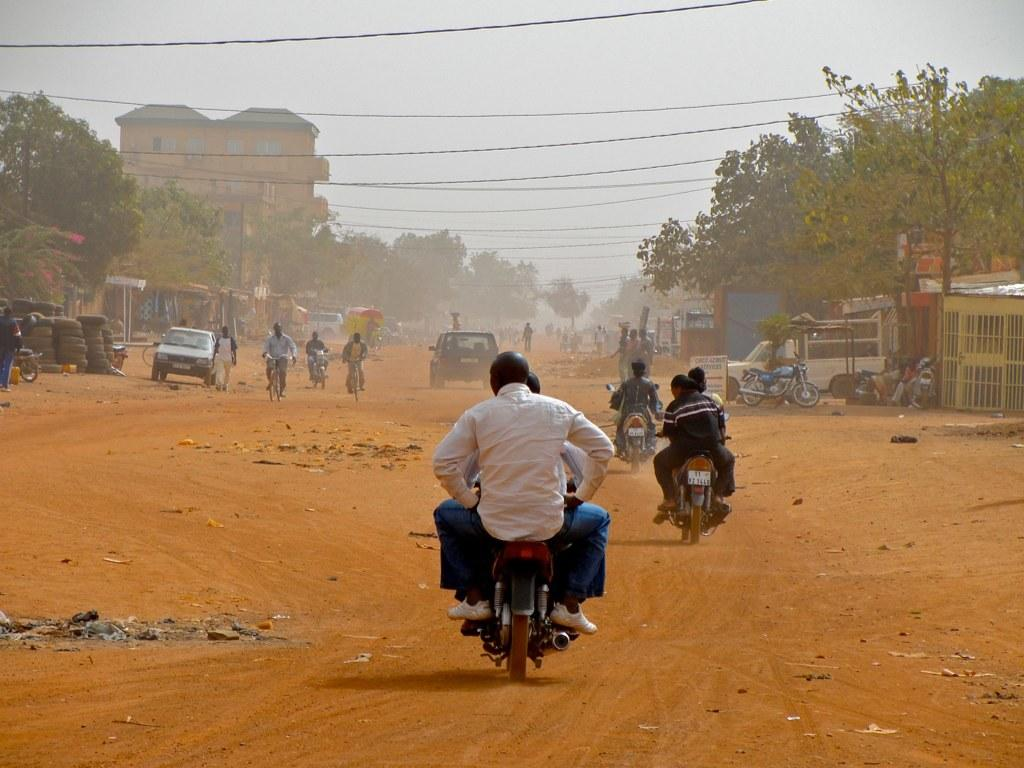What are the people in the image using to travel? The people in the image are using bicycles to travel. What type of vehicles can be seen in the image? There are vehicles in the image, but they are not specified. What is located in the foreground of the image? There are stalls in the foreground area of the image. What can be seen in the background of the image? Trees, buildings, and the sky are visible in the background of the image. Can you tell me how many bubbles are floating around the monkey in the image? There is no monkey or bubble present in the image. What type of curve can be seen on the bicycle in the image? The provided facts do not mention any specific curves on the bicycles in the image. 